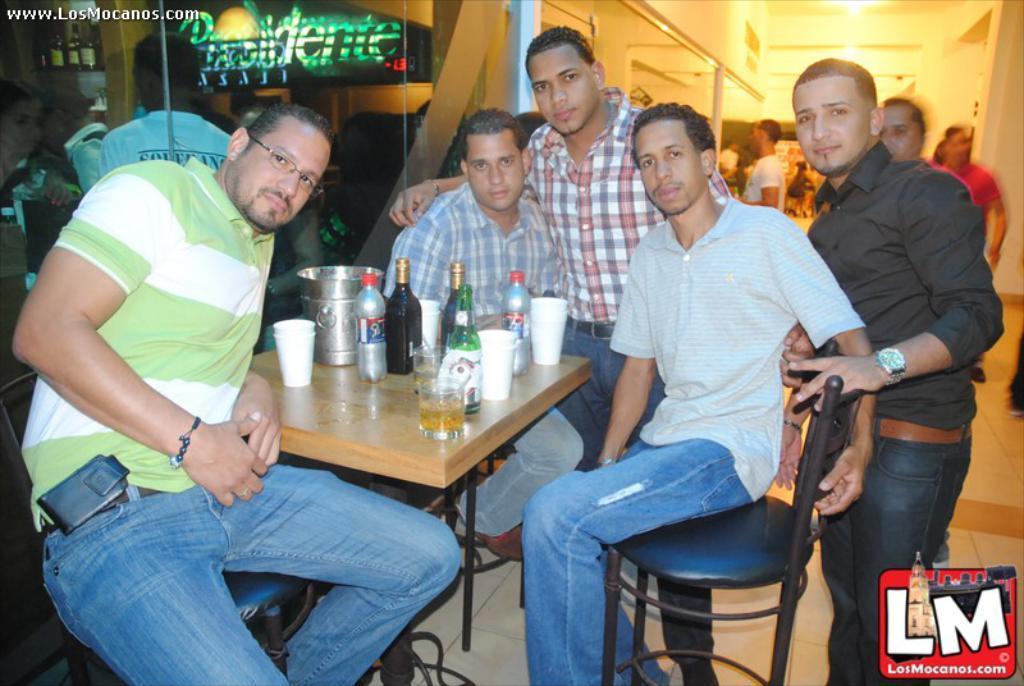In one or two sentences, can you explain what this image depicts? In the picture we can see a five people, three are sitting and two are standing, background we can see some other people are also standing. The people who are sitting on the chairs, they are near to the table. On the table we can find some bottles and glasses with wine. 